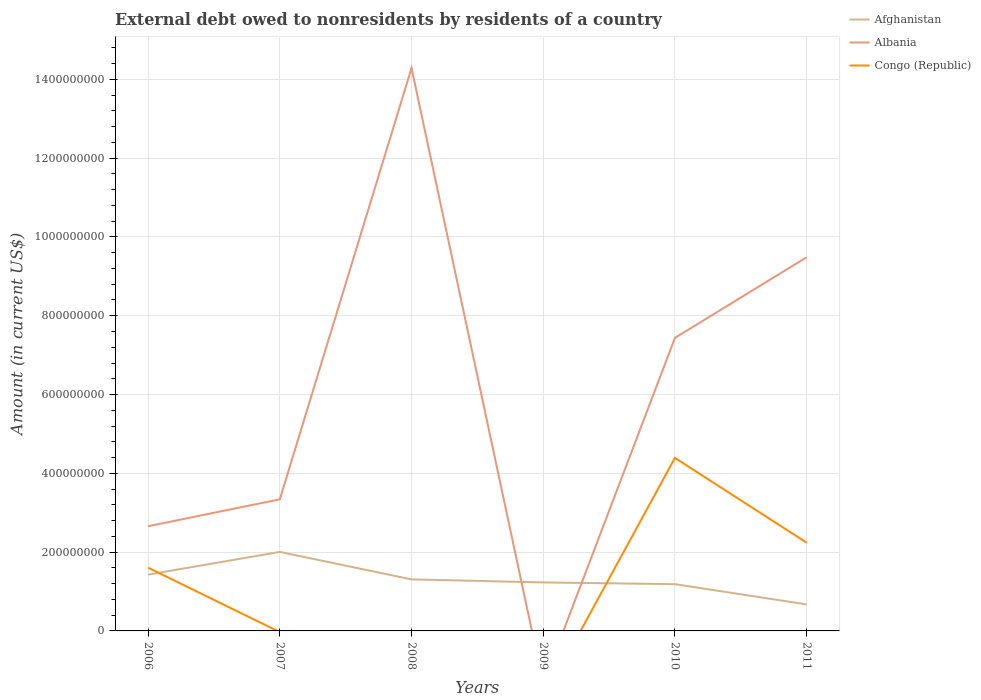How many different coloured lines are there?
Keep it short and to the point. 3. Across all years, what is the maximum external debt owed by residents in Afghanistan?
Provide a succinct answer. 6.73e+07. What is the total external debt owed by residents in Albania in the graph?
Provide a short and direct response. -6.14e+08. What is the difference between the highest and the second highest external debt owed by residents in Albania?
Keep it short and to the point. 1.43e+09. What is the difference between the highest and the lowest external debt owed by residents in Afghanistan?
Provide a short and direct response. 3. Is the external debt owed by residents in Congo (Republic) strictly greater than the external debt owed by residents in Afghanistan over the years?
Offer a very short reply. No. How many lines are there?
Offer a very short reply. 3. How many years are there in the graph?
Your answer should be very brief. 6. Does the graph contain any zero values?
Ensure brevity in your answer.  Yes. Does the graph contain grids?
Your response must be concise. Yes. What is the title of the graph?
Your answer should be very brief. External debt owed to nonresidents by residents of a country. Does "Netherlands" appear as one of the legend labels in the graph?
Make the answer very short. No. What is the Amount (in current US$) in Afghanistan in 2006?
Make the answer very short. 1.43e+08. What is the Amount (in current US$) of Albania in 2006?
Your answer should be compact. 2.66e+08. What is the Amount (in current US$) in Congo (Republic) in 2006?
Provide a succinct answer. 1.61e+08. What is the Amount (in current US$) in Afghanistan in 2007?
Offer a very short reply. 2.01e+08. What is the Amount (in current US$) of Albania in 2007?
Offer a very short reply. 3.34e+08. What is the Amount (in current US$) in Congo (Republic) in 2007?
Provide a short and direct response. 0. What is the Amount (in current US$) of Afghanistan in 2008?
Make the answer very short. 1.31e+08. What is the Amount (in current US$) in Albania in 2008?
Ensure brevity in your answer.  1.43e+09. What is the Amount (in current US$) in Afghanistan in 2009?
Ensure brevity in your answer.  1.23e+08. What is the Amount (in current US$) in Albania in 2009?
Offer a terse response. 0. What is the Amount (in current US$) in Afghanistan in 2010?
Your answer should be very brief. 1.19e+08. What is the Amount (in current US$) of Albania in 2010?
Your response must be concise. 7.44e+08. What is the Amount (in current US$) of Congo (Republic) in 2010?
Your answer should be compact. 4.39e+08. What is the Amount (in current US$) in Afghanistan in 2011?
Your answer should be compact. 6.73e+07. What is the Amount (in current US$) in Albania in 2011?
Offer a terse response. 9.48e+08. What is the Amount (in current US$) of Congo (Republic) in 2011?
Offer a terse response. 2.24e+08. Across all years, what is the maximum Amount (in current US$) of Afghanistan?
Make the answer very short. 2.01e+08. Across all years, what is the maximum Amount (in current US$) in Albania?
Give a very brief answer. 1.43e+09. Across all years, what is the maximum Amount (in current US$) in Congo (Republic)?
Your answer should be compact. 4.39e+08. Across all years, what is the minimum Amount (in current US$) in Afghanistan?
Offer a very short reply. 6.73e+07. Across all years, what is the minimum Amount (in current US$) in Albania?
Give a very brief answer. 0. Across all years, what is the minimum Amount (in current US$) in Congo (Republic)?
Provide a succinct answer. 0. What is the total Amount (in current US$) of Afghanistan in the graph?
Your response must be concise. 7.83e+08. What is the total Amount (in current US$) of Albania in the graph?
Give a very brief answer. 3.72e+09. What is the total Amount (in current US$) in Congo (Republic) in the graph?
Offer a terse response. 8.24e+08. What is the difference between the Amount (in current US$) of Afghanistan in 2006 and that in 2007?
Your response must be concise. -5.76e+07. What is the difference between the Amount (in current US$) in Albania in 2006 and that in 2007?
Give a very brief answer. -6.82e+07. What is the difference between the Amount (in current US$) of Afghanistan in 2006 and that in 2008?
Keep it short and to the point. 1.21e+07. What is the difference between the Amount (in current US$) of Albania in 2006 and that in 2008?
Give a very brief answer. -1.16e+09. What is the difference between the Amount (in current US$) of Afghanistan in 2006 and that in 2009?
Make the answer very short. 1.99e+07. What is the difference between the Amount (in current US$) of Afghanistan in 2006 and that in 2010?
Offer a terse response. 2.43e+07. What is the difference between the Amount (in current US$) of Albania in 2006 and that in 2010?
Your response must be concise. -4.78e+08. What is the difference between the Amount (in current US$) in Congo (Republic) in 2006 and that in 2010?
Offer a terse response. -2.79e+08. What is the difference between the Amount (in current US$) in Afghanistan in 2006 and that in 2011?
Offer a very short reply. 7.56e+07. What is the difference between the Amount (in current US$) of Albania in 2006 and that in 2011?
Keep it short and to the point. -6.83e+08. What is the difference between the Amount (in current US$) of Congo (Republic) in 2006 and that in 2011?
Make the answer very short. -6.34e+07. What is the difference between the Amount (in current US$) in Afghanistan in 2007 and that in 2008?
Offer a very short reply. 6.97e+07. What is the difference between the Amount (in current US$) in Albania in 2007 and that in 2008?
Your response must be concise. -1.09e+09. What is the difference between the Amount (in current US$) of Afghanistan in 2007 and that in 2009?
Your answer should be very brief. 7.75e+07. What is the difference between the Amount (in current US$) in Afghanistan in 2007 and that in 2010?
Offer a terse response. 8.19e+07. What is the difference between the Amount (in current US$) of Albania in 2007 and that in 2010?
Offer a very short reply. -4.10e+08. What is the difference between the Amount (in current US$) in Afghanistan in 2007 and that in 2011?
Provide a short and direct response. 1.33e+08. What is the difference between the Amount (in current US$) in Albania in 2007 and that in 2011?
Make the answer very short. -6.14e+08. What is the difference between the Amount (in current US$) of Afghanistan in 2008 and that in 2009?
Your answer should be compact. 7.76e+06. What is the difference between the Amount (in current US$) of Afghanistan in 2008 and that in 2010?
Your answer should be compact. 1.22e+07. What is the difference between the Amount (in current US$) of Albania in 2008 and that in 2010?
Provide a short and direct response. 6.85e+08. What is the difference between the Amount (in current US$) of Afghanistan in 2008 and that in 2011?
Ensure brevity in your answer.  6.35e+07. What is the difference between the Amount (in current US$) of Albania in 2008 and that in 2011?
Provide a short and direct response. 4.80e+08. What is the difference between the Amount (in current US$) in Afghanistan in 2009 and that in 2010?
Make the answer very short. 4.41e+06. What is the difference between the Amount (in current US$) of Afghanistan in 2009 and that in 2011?
Give a very brief answer. 5.58e+07. What is the difference between the Amount (in current US$) in Afghanistan in 2010 and that in 2011?
Ensure brevity in your answer.  5.14e+07. What is the difference between the Amount (in current US$) in Albania in 2010 and that in 2011?
Ensure brevity in your answer.  -2.05e+08. What is the difference between the Amount (in current US$) of Congo (Republic) in 2010 and that in 2011?
Offer a very short reply. 2.15e+08. What is the difference between the Amount (in current US$) in Afghanistan in 2006 and the Amount (in current US$) in Albania in 2007?
Ensure brevity in your answer.  -1.91e+08. What is the difference between the Amount (in current US$) of Afghanistan in 2006 and the Amount (in current US$) of Albania in 2008?
Provide a succinct answer. -1.29e+09. What is the difference between the Amount (in current US$) in Afghanistan in 2006 and the Amount (in current US$) in Albania in 2010?
Offer a terse response. -6.01e+08. What is the difference between the Amount (in current US$) in Afghanistan in 2006 and the Amount (in current US$) in Congo (Republic) in 2010?
Give a very brief answer. -2.96e+08. What is the difference between the Amount (in current US$) in Albania in 2006 and the Amount (in current US$) in Congo (Republic) in 2010?
Keep it short and to the point. -1.73e+08. What is the difference between the Amount (in current US$) of Afghanistan in 2006 and the Amount (in current US$) of Albania in 2011?
Your answer should be very brief. -8.06e+08. What is the difference between the Amount (in current US$) of Afghanistan in 2006 and the Amount (in current US$) of Congo (Republic) in 2011?
Offer a very short reply. -8.11e+07. What is the difference between the Amount (in current US$) in Albania in 2006 and the Amount (in current US$) in Congo (Republic) in 2011?
Provide a short and direct response. 4.18e+07. What is the difference between the Amount (in current US$) in Afghanistan in 2007 and the Amount (in current US$) in Albania in 2008?
Provide a succinct answer. -1.23e+09. What is the difference between the Amount (in current US$) of Afghanistan in 2007 and the Amount (in current US$) of Albania in 2010?
Offer a very short reply. -5.43e+08. What is the difference between the Amount (in current US$) of Afghanistan in 2007 and the Amount (in current US$) of Congo (Republic) in 2010?
Offer a very short reply. -2.39e+08. What is the difference between the Amount (in current US$) of Albania in 2007 and the Amount (in current US$) of Congo (Republic) in 2010?
Your answer should be compact. -1.05e+08. What is the difference between the Amount (in current US$) in Afghanistan in 2007 and the Amount (in current US$) in Albania in 2011?
Provide a succinct answer. -7.48e+08. What is the difference between the Amount (in current US$) in Afghanistan in 2007 and the Amount (in current US$) in Congo (Republic) in 2011?
Your answer should be compact. -2.35e+07. What is the difference between the Amount (in current US$) of Albania in 2007 and the Amount (in current US$) of Congo (Republic) in 2011?
Your response must be concise. 1.10e+08. What is the difference between the Amount (in current US$) of Afghanistan in 2008 and the Amount (in current US$) of Albania in 2010?
Offer a very short reply. -6.13e+08. What is the difference between the Amount (in current US$) of Afghanistan in 2008 and the Amount (in current US$) of Congo (Republic) in 2010?
Offer a terse response. -3.08e+08. What is the difference between the Amount (in current US$) of Albania in 2008 and the Amount (in current US$) of Congo (Republic) in 2010?
Your answer should be very brief. 9.89e+08. What is the difference between the Amount (in current US$) of Afghanistan in 2008 and the Amount (in current US$) of Albania in 2011?
Offer a terse response. -8.18e+08. What is the difference between the Amount (in current US$) of Afghanistan in 2008 and the Amount (in current US$) of Congo (Republic) in 2011?
Keep it short and to the point. -9.32e+07. What is the difference between the Amount (in current US$) of Albania in 2008 and the Amount (in current US$) of Congo (Republic) in 2011?
Provide a short and direct response. 1.20e+09. What is the difference between the Amount (in current US$) in Afghanistan in 2009 and the Amount (in current US$) in Albania in 2010?
Provide a short and direct response. -6.21e+08. What is the difference between the Amount (in current US$) of Afghanistan in 2009 and the Amount (in current US$) of Congo (Republic) in 2010?
Provide a short and direct response. -3.16e+08. What is the difference between the Amount (in current US$) in Afghanistan in 2009 and the Amount (in current US$) in Albania in 2011?
Provide a succinct answer. -8.25e+08. What is the difference between the Amount (in current US$) of Afghanistan in 2009 and the Amount (in current US$) of Congo (Republic) in 2011?
Provide a short and direct response. -1.01e+08. What is the difference between the Amount (in current US$) of Afghanistan in 2010 and the Amount (in current US$) of Albania in 2011?
Offer a terse response. -8.30e+08. What is the difference between the Amount (in current US$) in Afghanistan in 2010 and the Amount (in current US$) in Congo (Republic) in 2011?
Offer a very short reply. -1.05e+08. What is the difference between the Amount (in current US$) in Albania in 2010 and the Amount (in current US$) in Congo (Republic) in 2011?
Your response must be concise. 5.20e+08. What is the average Amount (in current US$) of Afghanistan per year?
Your answer should be compact. 1.31e+08. What is the average Amount (in current US$) of Albania per year?
Give a very brief answer. 6.20e+08. What is the average Amount (in current US$) in Congo (Republic) per year?
Give a very brief answer. 1.37e+08. In the year 2006, what is the difference between the Amount (in current US$) of Afghanistan and Amount (in current US$) of Albania?
Give a very brief answer. -1.23e+08. In the year 2006, what is the difference between the Amount (in current US$) in Afghanistan and Amount (in current US$) in Congo (Republic)?
Provide a short and direct response. -1.76e+07. In the year 2006, what is the difference between the Amount (in current US$) in Albania and Amount (in current US$) in Congo (Republic)?
Offer a terse response. 1.05e+08. In the year 2007, what is the difference between the Amount (in current US$) of Afghanistan and Amount (in current US$) of Albania?
Provide a succinct answer. -1.33e+08. In the year 2008, what is the difference between the Amount (in current US$) of Afghanistan and Amount (in current US$) of Albania?
Offer a very short reply. -1.30e+09. In the year 2010, what is the difference between the Amount (in current US$) in Afghanistan and Amount (in current US$) in Albania?
Offer a terse response. -6.25e+08. In the year 2010, what is the difference between the Amount (in current US$) of Afghanistan and Amount (in current US$) of Congo (Republic)?
Offer a very short reply. -3.21e+08. In the year 2010, what is the difference between the Amount (in current US$) in Albania and Amount (in current US$) in Congo (Republic)?
Offer a terse response. 3.05e+08. In the year 2011, what is the difference between the Amount (in current US$) in Afghanistan and Amount (in current US$) in Albania?
Ensure brevity in your answer.  -8.81e+08. In the year 2011, what is the difference between the Amount (in current US$) of Afghanistan and Amount (in current US$) of Congo (Republic)?
Your answer should be very brief. -1.57e+08. In the year 2011, what is the difference between the Amount (in current US$) of Albania and Amount (in current US$) of Congo (Republic)?
Provide a short and direct response. 7.24e+08. What is the ratio of the Amount (in current US$) in Afghanistan in 2006 to that in 2007?
Offer a terse response. 0.71. What is the ratio of the Amount (in current US$) in Albania in 2006 to that in 2007?
Your answer should be very brief. 0.8. What is the ratio of the Amount (in current US$) in Afghanistan in 2006 to that in 2008?
Give a very brief answer. 1.09. What is the ratio of the Amount (in current US$) of Albania in 2006 to that in 2008?
Ensure brevity in your answer.  0.19. What is the ratio of the Amount (in current US$) of Afghanistan in 2006 to that in 2009?
Offer a very short reply. 1.16. What is the ratio of the Amount (in current US$) of Afghanistan in 2006 to that in 2010?
Make the answer very short. 1.2. What is the ratio of the Amount (in current US$) of Albania in 2006 to that in 2010?
Your answer should be very brief. 0.36. What is the ratio of the Amount (in current US$) of Congo (Republic) in 2006 to that in 2010?
Provide a succinct answer. 0.37. What is the ratio of the Amount (in current US$) of Afghanistan in 2006 to that in 2011?
Offer a terse response. 2.12. What is the ratio of the Amount (in current US$) of Albania in 2006 to that in 2011?
Keep it short and to the point. 0.28. What is the ratio of the Amount (in current US$) of Congo (Republic) in 2006 to that in 2011?
Offer a terse response. 0.72. What is the ratio of the Amount (in current US$) of Afghanistan in 2007 to that in 2008?
Offer a terse response. 1.53. What is the ratio of the Amount (in current US$) in Albania in 2007 to that in 2008?
Your answer should be compact. 0.23. What is the ratio of the Amount (in current US$) in Afghanistan in 2007 to that in 2009?
Offer a terse response. 1.63. What is the ratio of the Amount (in current US$) in Afghanistan in 2007 to that in 2010?
Ensure brevity in your answer.  1.69. What is the ratio of the Amount (in current US$) in Albania in 2007 to that in 2010?
Provide a succinct answer. 0.45. What is the ratio of the Amount (in current US$) in Afghanistan in 2007 to that in 2011?
Offer a terse response. 2.98. What is the ratio of the Amount (in current US$) in Albania in 2007 to that in 2011?
Your answer should be compact. 0.35. What is the ratio of the Amount (in current US$) in Afghanistan in 2008 to that in 2009?
Keep it short and to the point. 1.06. What is the ratio of the Amount (in current US$) of Afghanistan in 2008 to that in 2010?
Keep it short and to the point. 1.1. What is the ratio of the Amount (in current US$) in Albania in 2008 to that in 2010?
Give a very brief answer. 1.92. What is the ratio of the Amount (in current US$) in Afghanistan in 2008 to that in 2011?
Give a very brief answer. 1.94. What is the ratio of the Amount (in current US$) of Albania in 2008 to that in 2011?
Your answer should be very brief. 1.51. What is the ratio of the Amount (in current US$) of Afghanistan in 2009 to that in 2010?
Ensure brevity in your answer.  1.04. What is the ratio of the Amount (in current US$) of Afghanistan in 2009 to that in 2011?
Make the answer very short. 1.83. What is the ratio of the Amount (in current US$) in Afghanistan in 2010 to that in 2011?
Provide a succinct answer. 1.76. What is the ratio of the Amount (in current US$) of Albania in 2010 to that in 2011?
Offer a very short reply. 0.78. What is the ratio of the Amount (in current US$) in Congo (Republic) in 2010 to that in 2011?
Keep it short and to the point. 1.96. What is the difference between the highest and the second highest Amount (in current US$) in Afghanistan?
Offer a very short reply. 5.76e+07. What is the difference between the highest and the second highest Amount (in current US$) in Albania?
Offer a terse response. 4.80e+08. What is the difference between the highest and the second highest Amount (in current US$) in Congo (Republic)?
Offer a very short reply. 2.15e+08. What is the difference between the highest and the lowest Amount (in current US$) of Afghanistan?
Keep it short and to the point. 1.33e+08. What is the difference between the highest and the lowest Amount (in current US$) in Albania?
Provide a succinct answer. 1.43e+09. What is the difference between the highest and the lowest Amount (in current US$) of Congo (Republic)?
Make the answer very short. 4.39e+08. 